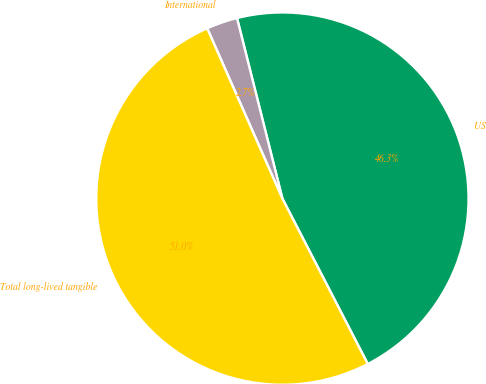Convert chart. <chart><loc_0><loc_0><loc_500><loc_500><pie_chart><fcel>US<fcel>International<fcel>Total long-lived tangible<nl><fcel>46.34%<fcel>2.7%<fcel>50.97%<nl></chart> 